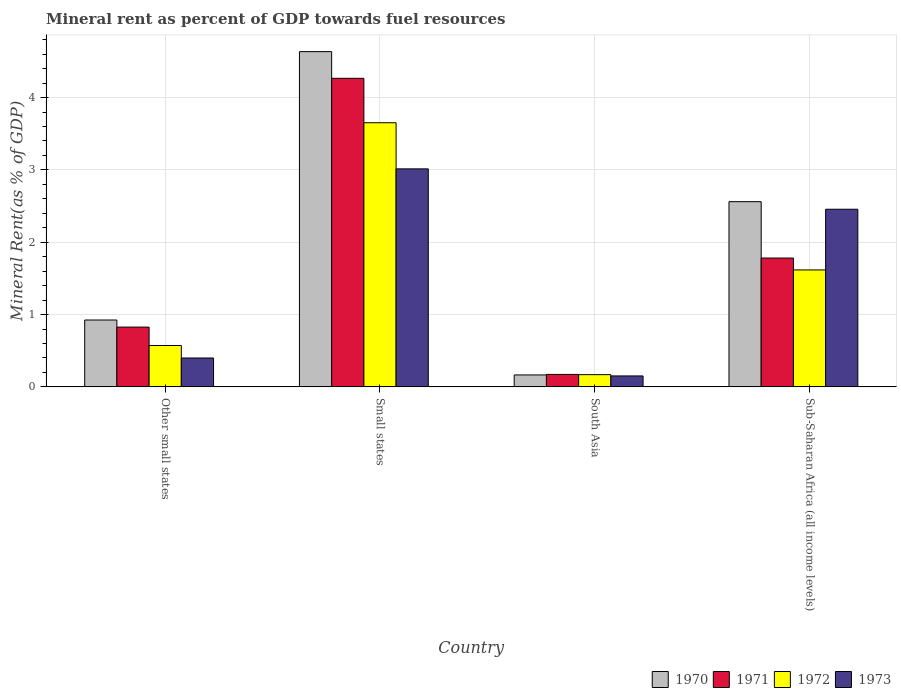How many different coloured bars are there?
Offer a terse response. 4. How many groups of bars are there?
Your answer should be very brief. 4. Are the number of bars per tick equal to the number of legend labels?
Your answer should be very brief. Yes. What is the label of the 4th group of bars from the left?
Keep it short and to the point. Sub-Saharan Africa (all income levels). What is the mineral rent in 1970 in Small states?
Give a very brief answer. 4.63. Across all countries, what is the maximum mineral rent in 1971?
Your response must be concise. 4.27. Across all countries, what is the minimum mineral rent in 1970?
Make the answer very short. 0.16. In which country was the mineral rent in 1971 maximum?
Provide a succinct answer. Small states. What is the total mineral rent in 1973 in the graph?
Offer a very short reply. 6.02. What is the difference between the mineral rent in 1970 in Small states and that in South Asia?
Provide a short and direct response. 4.47. What is the difference between the mineral rent in 1973 in South Asia and the mineral rent in 1971 in Small states?
Offer a very short reply. -4.11. What is the average mineral rent in 1971 per country?
Your answer should be compact. 1.76. What is the difference between the mineral rent of/in 1972 and mineral rent of/in 1970 in Small states?
Give a very brief answer. -0.98. In how many countries, is the mineral rent in 1970 greater than 3.8 %?
Provide a short and direct response. 1. What is the ratio of the mineral rent in 1970 in Other small states to that in Sub-Saharan Africa (all income levels)?
Provide a short and direct response. 0.36. Is the difference between the mineral rent in 1972 in Other small states and Sub-Saharan Africa (all income levels) greater than the difference between the mineral rent in 1970 in Other small states and Sub-Saharan Africa (all income levels)?
Make the answer very short. Yes. What is the difference between the highest and the second highest mineral rent in 1972?
Keep it short and to the point. -1.04. What is the difference between the highest and the lowest mineral rent in 1972?
Offer a very short reply. 3.48. In how many countries, is the mineral rent in 1971 greater than the average mineral rent in 1971 taken over all countries?
Make the answer very short. 2. Is the sum of the mineral rent in 1972 in Small states and Sub-Saharan Africa (all income levels) greater than the maximum mineral rent in 1971 across all countries?
Provide a short and direct response. Yes. What does the 4th bar from the left in Other small states represents?
Make the answer very short. 1973. Are all the bars in the graph horizontal?
Keep it short and to the point. No. How many countries are there in the graph?
Give a very brief answer. 4. Does the graph contain grids?
Provide a succinct answer. Yes. How are the legend labels stacked?
Give a very brief answer. Horizontal. What is the title of the graph?
Keep it short and to the point. Mineral rent as percent of GDP towards fuel resources. Does "2007" appear as one of the legend labels in the graph?
Give a very brief answer. No. What is the label or title of the Y-axis?
Ensure brevity in your answer.  Mineral Rent(as % of GDP). What is the Mineral Rent(as % of GDP) in 1970 in Other small states?
Offer a terse response. 0.92. What is the Mineral Rent(as % of GDP) of 1971 in Other small states?
Your answer should be very brief. 0.83. What is the Mineral Rent(as % of GDP) in 1972 in Other small states?
Offer a terse response. 0.57. What is the Mineral Rent(as % of GDP) of 1973 in Other small states?
Offer a terse response. 0.4. What is the Mineral Rent(as % of GDP) in 1970 in Small states?
Offer a very short reply. 4.63. What is the Mineral Rent(as % of GDP) in 1971 in Small states?
Your answer should be compact. 4.27. What is the Mineral Rent(as % of GDP) in 1972 in Small states?
Your answer should be compact. 3.65. What is the Mineral Rent(as % of GDP) of 1973 in Small states?
Provide a succinct answer. 3.01. What is the Mineral Rent(as % of GDP) of 1970 in South Asia?
Give a very brief answer. 0.16. What is the Mineral Rent(as % of GDP) in 1971 in South Asia?
Provide a succinct answer. 0.17. What is the Mineral Rent(as % of GDP) of 1972 in South Asia?
Provide a short and direct response. 0.17. What is the Mineral Rent(as % of GDP) in 1973 in South Asia?
Offer a terse response. 0.15. What is the Mineral Rent(as % of GDP) of 1970 in Sub-Saharan Africa (all income levels)?
Offer a terse response. 2.56. What is the Mineral Rent(as % of GDP) of 1971 in Sub-Saharan Africa (all income levels)?
Your response must be concise. 1.78. What is the Mineral Rent(as % of GDP) of 1972 in Sub-Saharan Africa (all income levels)?
Make the answer very short. 1.62. What is the Mineral Rent(as % of GDP) of 1973 in Sub-Saharan Africa (all income levels)?
Provide a succinct answer. 2.46. Across all countries, what is the maximum Mineral Rent(as % of GDP) of 1970?
Give a very brief answer. 4.63. Across all countries, what is the maximum Mineral Rent(as % of GDP) of 1971?
Provide a short and direct response. 4.27. Across all countries, what is the maximum Mineral Rent(as % of GDP) of 1972?
Your response must be concise. 3.65. Across all countries, what is the maximum Mineral Rent(as % of GDP) in 1973?
Offer a very short reply. 3.01. Across all countries, what is the minimum Mineral Rent(as % of GDP) of 1970?
Give a very brief answer. 0.16. Across all countries, what is the minimum Mineral Rent(as % of GDP) of 1971?
Make the answer very short. 0.17. Across all countries, what is the minimum Mineral Rent(as % of GDP) in 1972?
Your answer should be compact. 0.17. Across all countries, what is the minimum Mineral Rent(as % of GDP) of 1973?
Give a very brief answer. 0.15. What is the total Mineral Rent(as % of GDP) in 1970 in the graph?
Give a very brief answer. 8.28. What is the total Mineral Rent(as % of GDP) in 1971 in the graph?
Offer a terse response. 7.05. What is the total Mineral Rent(as % of GDP) of 1972 in the graph?
Your answer should be very brief. 6.01. What is the total Mineral Rent(as % of GDP) in 1973 in the graph?
Make the answer very short. 6.02. What is the difference between the Mineral Rent(as % of GDP) in 1970 in Other small states and that in Small states?
Your answer should be very brief. -3.71. What is the difference between the Mineral Rent(as % of GDP) in 1971 in Other small states and that in Small states?
Keep it short and to the point. -3.44. What is the difference between the Mineral Rent(as % of GDP) in 1972 in Other small states and that in Small states?
Provide a succinct answer. -3.08. What is the difference between the Mineral Rent(as % of GDP) in 1973 in Other small states and that in Small states?
Your response must be concise. -2.61. What is the difference between the Mineral Rent(as % of GDP) in 1970 in Other small states and that in South Asia?
Provide a short and direct response. 0.76. What is the difference between the Mineral Rent(as % of GDP) in 1971 in Other small states and that in South Asia?
Keep it short and to the point. 0.65. What is the difference between the Mineral Rent(as % of GDP) in 1972 in Other small states and that in South Asia?
Provide a short and direct response. 0.4. What is the difference between the Mineral Rent(as % of GDP) in 1973 in Other small states and that in South Asia?
Offer a very short reply. 0.25. What is the difference between the Mineral Rent(as % of GDP) in 1970 in Other small states and that in Sub-Saharan Africa (all income levels)?
Offer a very short reply. -1.64. What is the difference between the Mineral Rent(as % of GDP) in 1971 in Other small states and that in Sub-Saharan Africa (all income levels)?
Keep it short and to the point. -0.95. What is the difference between the Mineral Rent(as % of GDP) in 1972 in Other small states and that in Sub-Saharan Africa (all income levels)?
Offer a very short reply. -1.04. What is the difference between the Mineral Rent(as % of GDP) of 1973 in Other small states and that in Sub-Saharan Africa (all income levels)?
Provide a succinct answer. -2.06. What is the difference between the Mineral Rent(as % of GDP) in 1970 in Small states and that in South Asia?
Your response must be concise. 4.47. What is the difference between the Mineral Rent(as % of GDP) of 1971 in Small states and that in South Asia?
Keep it short and to the point. 4.09. What is the difference between the Mineral Rent(as % of GDP) of 1972 in Small states and that in South Asia?
Give a very brief answer. 3.48. What is the difference between the Mineral Rent(as % of GDP) of 1973 in Small states and that in South Asia?
Provide a short and direct response. 2.86. What is the difference between the Mineral Rent(as % of GDP) in 1970 in Small states and that in Sub-Saharan Africa (all income levels)?
Your answer should be very brief. 2.07. What is the difference between the Mineral Rent(as % of GDP) in 1971 in Small states and that in Sub-Saharan Africa (all income levels)?
Your answer should be compact. 2.49. What is the difference between the Mineral Rent(as % of GDP) in 1972 in Small states and that in Sub-Saharan Africa (all income levels)?
Keep it short and to the point. 2.04. What is the difference between the Mineral Rent(as % of GDP) of 1973 in Small states and that in Sub-Saharan Africa (all income levels)?
Give a very brief answer. 0.56. What is the difference between the Mineral Rent(as % of GDP) of 1970 in South Asia and that in Sub-Saharan Africa (all income levels)?
Give a very brief answer. -2.4. What is the difference between the Mineral Rent(as % of GDP) of 1971 in South Asia and that in Sub-Saharan Africa (all income levels)?
Ensure brevity in your answer.  -1.61. What is the difference between the Mineral Rent(as % of GDP) in 1972 in South Asia and that in Sub-Saharan Africa (all income levels)?
Provide a succinct answer. -1.45. What is the difference between the Mineral Rent(as % of GDP) in 1973 in South Asia and that in Sub-Saharan Africa (all income levels)?
Ensure brevity in your answer.  -2.3. What is the difference between the Mineral Rent(as % of GDP) in 1970 in Other small states and the Mineral Rent(as % of GDP) in 1971 in Small states?
Make the answer very short. -3.34. What is the difference between the Mineral Rent(as % of GDP) in 1970 in Other small states and the Mineral Rent(as % of GDP) in 1972 in Small states?
Provide a succinct answer. -2.73. What is the difference between the Mineral Rent(as % of GDP) of 1970 in Other small states and the Mineral Rent(as % of GDP) of 1973 in Small states?
Keep it short and to the point. -2.09. What is the difference between the Mineral Rent(as % of GDP) in 1971 in Other small states and the Mineral Rent(as % of GDP) in 1972 in Small states?
Give a very brief answer. -2.83. What is the difference between the Mineral Rent(as % of GDP) of 1971 in Other small states and the Mineral Rent(as % of GDP) of 1973 in Small states?
Keep it short and to the point. -2.19. What is the difference between the Mineral Rent(as % of GDP) in 1972 in Other small states and the Mineral Rent(as % of GDP) in 1973 in Small states?
Give a very brief answer. -2.44. What is the difference between the Mineral Rent(as % of GDP) in 1970 in Other small states and the Mineral Rent(as % of GDP) in 1971 in South Asia?
Give a very brief answer. 0.75. What is the difference between the Mineral Rent(as % of GDP) of 1970 in Other small states and the Mineral Rent(as % of GDP) of 1972 in South Asia?
Make the answer very short. 0.76. What is the difference between the Mineral Rent(as % of GDP) of 1970 in Other small states and the Mineral Rent(as % of GDP) of 1973 in South Asia?
Ensure brevity in your answer.  0.77. What is the difference between the Mineral Rent(as % of GDP) of 1971 in Other small states and the Mineral Rent(as % of GDP) of 1972 in South Asia?
Ensure brevity in your answer.  0.66. What is the difference between the Mineral Rent(as % of GDP) of 1971 in Other small states and the Mineral Rent(as % of GDP) of 1973 in South Asia?
Offer a terse response. 0.68. What is the difference between the Mineral Rent(as % of GDP) in 1972 in Other small states and the Mineral Rent(as % of GDP) in 1973 in South Asia?
Keep it short and to the point. 0.42. What is the difference between the Mineral Rent(as % of GDP) of 1970 in Other small states and the Mineral Rent(as % of GDP) of 1971 in Sub-Saharan Africa (all income levels)?
Give a very brief answer. -0.86. What is the difference between the Mineral Rent(as % of GDP) of 1970 in Other small states and the Mineral Rent(as % of GDP) of 1972 in Sub-Saharan Africa (all income levels)?
Ensure brevity in your answer.  -0.69. What is the difference between the Mineral Rent(as % of GDP) of 1970 in Other small states and the Mineral Rent(as % of GDP) of 1973 in Sub-Saharan Africa (all income levels)?
Your answer should be very brief. -1.53. What is the difference between the Mineral Rent(as % of GDP) in 1971 in Other small states and the Mineral Rent(as % of GDP) in 1972 in Sub-Saharan Africa (all income levels)?
Make the answer very short. -0.79. What is the difference between the Mineral Rent(as % of GDP) of 1971 in Other small states and the Mineral Rent(as % of GDP) of 1973 in Sub-Saharan Africa (all income levels)?
Keep it short and to the point. -1.63. What is the difference between the Mineral Rent(as % of GDP) in 1972 in Other small states and the Mineral Rent(as % of GDP) in 1973 in Sub-Saharan Africa (all income levels)?
Make the answer very short. -1.88. What is the difference between the Mineral Rent(as % of GDP) in 1970 in Small states and the Mineral Rent(as % of GDP) in 1971 in South Asia?
Your response must be concise. 4.46. What is the difference between the Mineral Rent(as % of GDP) in 1970 in Small states and the Mineral Rent(as % of GDP) in 1972 in South Asia?
Give a very brief answer. 4.47. What is the difference between the Mineral Rent(as % of GDP) in 1970 in Small states and the Mineral Rent(as % of GDP) in 1973 in South Asia?
Provide a succinct answer. 4.48. What is the difference between the Mineral Rent(as % of GDP) in 1971 in Small states and the Mineral Rent(as % of GDP) in 1972 in South Asia?
Give a very brief answer. 4.1. What is the difference between the Mineral Rent(as % of GDP) in 1971 in Small states and the Mineral Rent(as % of GDP) in 1973 in South Asia?
Your answer should be compact. 4.11. What is the difference between the Mineral Rent(as % of GDP) of 1972 in Small states and the Mineral Rent(as % of GDP) of 1973 in South Asia?
Your answer should be compact. 3.5. What is the difference between the Mineral Rent(as % of GDP) of 1970 in Small states and the Mineral Rent(as % of GDP) of 1971 in Sub-Saharan Africa (all income levels)?
Your answer should be compact. 2.85. What is the difference between the Mineral Rent(as % of GDP) in 1970 in Small states and the Mineral Rent(as % of GDP) in 1972 in Sub-Saharan Africa (all income levels)?
Make the answer very short. 3.02. What is the difference between the Mineral Rent(as % of GDP) in 1970 in Small states and the Mineral Rent(as % of GDP) in 1973 in Sub-Saharan Africa (all income levels)?
Give a very brief answer. 2.18. What is the difference between the Mineral Rent(as % of GDP) in 1971 in Small states and the Mineral Rent(as % of GDP) in 1972 in Sub-Saharan Africa (all income levels)?
Provide a succinct answer. 2.65. What is the difference between the Mineral Rent(as % of GDP) in 1971 in Small states and the Mineral Rent(as % of GDP) in 1973 in Sub-Saharan Africa (all income levels)?
Keep it short and to the point. 1.81. What is the difference between the Mineral Rent(as % of GDP) in 1972 in Small states and the Mineral Rent(as % of GDP) in 1973 in Sub-Saharan Africa (all income levels)?
Make the answer very short. 1.2. What is the difference between the Mineral Rent(as % of GDP) of 1970 in South Asia and the Mineral Rent(as % of GDP) of 1971 in Sub-Saharan Africa (all income levels)?
Your answer should be very brief. -1.62. What is the difference between the Mineral Rent(as % of GDP) of 1970 in South Asia and the Mineral Rent(as % of GDP) of 1972 in Sub-Saharan Africa (all income levels)?
Provide a short and direct response. -1.45. What is the difference between the Mineral Rent(as % of GDP) of 1970 in South Asia and the Mineral Rent(as % of GDP) of 1973 in Sub-Saharan Africa (all income levels)?
Ensure brevity in your answer.  -2.29. What is the difference between the Mineral Rent(as % of GDP) of 1971 in South Asia and the Mineral Rent(as % of GDP) of 1972 in Sub-Saharan Africa (all income levels)?
Your answer should be very brief. -1.44. What is the difference between the Mineral Rent(as % of GDP) in 1971 in South Asia and the Mineral Rent(as % of GDP) in 1973 in Sub-Saharan Africa (all income levels)?
Provide a succinct answer. -2.28. What is the difference between the Mineral Rent(as % of GDP) of 1972 in South Asia and the Mineral Rent(as % of GDP) of 1973 in Sub-Saharan Africa (all income levels)?
Your answer should be very brief. -2.29. What is the average Mineral Rent(as % of GDP) of 1970 per country?
Your response must be concise. 2.07. What is the average Mineral Rent(as % of GDP) in 1971 per country?
Give a very brief answer. 1.76. What is the average Mineral Rent(as % of GDP) of 1972 per country?
Your answer should be very brief. 1.5. What is the average Mineral Rent(as % of GDP) of 1973 per country?
Ensure brevity in your answer.  1.5. What is the difference between the Mineral Rent(as % of GDP) in 1970 and Mineral Rent(as % of GDP) in 1971 in Other small states?
Offer a very short reply. 0.1. What is the difference between the Mineral Rent(as % of GDP) of 1970 and Mineral Rent(as % of GDP) of 1972 in Other small states?
Make the answer very short. 0.35. What is the difference between the Mineral Rent(as % of GDP) in 1970 and Mineral Rent(as % of GDP) in 1973 in Other small states?
Provide a short and direct response. 0.53. What is the difference between the Mineral Rent(as % of GDP) of 1971 and Mineral Rent(as % of GDP) of 1972 in Other small states?
Ensure brevity in your answer.  0.25. What is the difference between the Mineral Rent(as % of GDP) in 1971 and Mineral Rent(as % of GDP) in 1973 in Other small states?
Offer a very short reply. 0.43. What is the difference between the Mineral Rent(as % of GDP) of 1972 and Mineral Rent(as % of GDP) of 1973 in Other small states?
Give a very brief answer. 0.17. What is the difference between the Mineral Rent(as % of GDP) in 1970 and Mineral Rent(as % of GDP) in 1971 in Small states?
Your response must be concise. 0.37. What is the difference between the Mineral Rent(as % of GDP) in 1970 and Mineral Rent(as % of GDP) in 1972 in Small states?
Give a very brief answer. 0.98. What is the difference between the Mineral Rent(as % of GDP) of 1970 and Mineral Rent(as % of GDP) of 1973 in Small states?
Offer a very short reply. 1.62. What is the difference between the Mineral Rent(as % of GDP) of 1971 and Mineral Rent(as % of GDP) of 1972 in Small states?
Give a very brief answer. 0.61. What is the difference between the Mineral Rent(as % of GDP) of 1971 and Mineral Rent(as % of GDP) of 1973 in Small states?
Offer a terse response. 1.25. What is the difference between the Mineral Rent(as % of GDP) of 1972 and Mineral Rent(as % of GDP) of 1973 in Small states?
Provide a short and direct response. 0.64. What is the difference between the Mineral Rent(as % of GDP) of 1970 and Mineral Rent(as % of GDP) of 1971 in South Asia?
Make the answer very short. -0.01. What is the difference between the Mineral Rent(as % of GDP) in 1970 and Mineral Rent(as % of GDP) in 1972 in South Asia?
Offer a very short reply. -0. What is the difference between the Mineral Rent(as % of GDP) of 1970 and Mineral Rent(as % of GDP) of 1973 in South Asia?
Your response must be concise. 0.01. What is the difference between the Mineral Rent(as % of GDP) in 1971 and Mineral Rent(as % of GDP) in 1972 in South Asia?
Your response must be concise. 0. What is the difference between the Mineral Rent(as % of GDP) in 1971 and Mineral Rent(as % of GDP) in 1973 in South Asia?
Your answer should be compact. 0.02. What is the difference between the Mineral Rent(as % of GDP) of 1972 and Mineral Rent(as % of GDP) of 1973 in South Asia?
Keep it short and to the point. 0.02. What is the difference between the Mineral Rent(as % of GDP) in 1970 and Mineral Rent(as % of GDP) in 1971 in Sub-Saharan Africa (all income levels)?
Keep it short and to the point. 0.78. What is the difference between the Mineral Rent(as % of GDP) in 1970 and Mineral Rent(as % of GDP) in 1972 in Sub-Saharan Africa (all income levels)?
Your answer should be very brief. 0.94. What is the difference between the Mineral Rent(as % of GDP) in 1970 and Mineral Rent(as % of GDP) in 1973 in Sub-Saharan Africa (all income levels)?
Provide a short and direct response. 0.1. What is the difference between the Mineral Rent(as % of GDP) in 1971 and Mineral Rent(as % of GDP) in 1972 in Sub-Saharan Africa (all income levels)?
Your answer should be compact. 0.16. What is the difference between the Mineral Rent(as % of GDP) of 1971 and Mineral Rent(as % of GDP) of 1973 in Sub-Saharan Africa (all income levels)?
Your answer should be compact. -0.67. What is the difference between the Mineral Rent(as % of GDP) in 1972 and Mineral Rent(as % of GDP) in 1973 in Sub-Saharan Africa (all income levels)?
Keep it short and to the point. -0.84. What is the ratio of the Mineral Rent(as % of GDP) in 1970 in Other small states to that in Small states?
Your answer should be compact. 0.2. What is the ratio of the Mineral Rent(as % of GDP) of 1971 in Other small states to that in Small states?
Your answer should be very brief. 0.19. What is the ratio of the Mineral Rent(as % of GDP) in 1972 in Other small states to that in Small states?
Keep it short and to the point. 0.16. What is the ratio of the Mineral Rent(as % of GDP) in 1973 in Other small states to that in Small states?
Provide a succinct answer. 0.13. What is the ratio of the Mineral Rent(as % of GDP) of 1970 in Other small states to that in South Asia?
Offer a terse response. 5.61. What is the ratio of the Mineral Rent(as % of GDP) of 1971 in Other small states to that in South Asia?
Your response must be concise. 4.8. What is the ratio of the Mineral Rent(as % of GDP) in 1972 in Other small states to that in South Asia?
Keep it short and to the point. 3.38. What is the ratio of the Mineral Rent(as % of GDP) in 1973 in Other small states to that in South Asia?
Your response must be concise. 2.64. What is the ratio of the Mineral Rent(as % of GDP) of 1970 in Other small states to that in Sub-Saharan Africa (all income levels)?
Keep it short and to the point. 0.36. What is the ratio of the Mineral Rent(as % of GDP) of 1971 in Other small states to that in Sub-Saharan Africa (all income levels)?
Give a very brief answer. 0.46. What is the ratio of the Mineral Rent(as % of GDP) of 1972 in Other small states to that in Sub-Saharan Africa (all income levels)?
Provide a short and direct response. 0.35. What is the ratio of the Mineral Rent(as % of GDP) of 1973 in Other small states to that in Sub-Saharan Africa (all income levels)?
Provide a succinct answer. 0.16. What is the ratio of the Mineral Rent(as % of GDP) of 1970 in Small states to that in South Asia?
Provide a succinct answer. 28.13. What is the ratio of the Mineral Rent(as % of GDP) of 1971 in Small states to that in South Asia?
Provide a succinct answer. 24.77. What is the ratio of the Mineral Rent(as % of GDP) of 1972 in Small states to that in South Asia?
Offer a very short reply. 21.6. What is the ratio of the Mineral Rent(as % of GDP) in 1973 in Small states to that in South Asia?
Keep it short and to the point. 19.93. What is the ratio of the Mineral Rent(as % of GDP) of 1970 in Small states to that in Sub-Saharan Africa (all income levels)?
Your response must be concise. 1.81. What is the ratio of the Mineral Rent(as % of GDP) in 1971 in Small states to that in Sub-Saharan Africa (all income levels)?
Provide a succinct answer. 2.4. What is the ratio of the Mineral Rent(as % of GDP) in 1972 in Small states to that in Sub-Saharan Africa (all income levels)?
Provide a succinct answer. 2.26. What is the ratio of the Mineral Rent(as % of GDP) in 1973 in Small states to that in Sub-Saharan Africa (all income levels)?
Keep it short and to the point. 1.23. What is the ratio of the Mineral Rent(as % of GDP) of 1970 in South Asia to that in Sub-Saharan Africa (all income levels)?
Offer a very short reply. 0.06. What is the ratio of the Mineral Rent(as % of GDP) of 1971 in South Asia to that in Sub-Saharan Africa (all income levels)?
Your answer should be very brief. 0.1. What is the ratio of the Mineral Rent(as % of GDP) in 1972 in South Asia to that in Sub-Saharan Africa (all income levels)?
Your answer should be very brief. 0.1. What is the ratio of the Mineral Rent(as % of GDP) in 1973 in South Asia to that in Sub-Saharan Africa (all income levels)?
Your response must be concise. 0.06. What is the difference between the highest and the second highest Mineral Rent(as % of GDP) in 1970?
Ensure brevity in your answer.  2.07. What is the difference between the highest and the second highest Mineral Rent(as % of GDP) of 1971?
Make the answer very short. 2.49. What is the difference between the highest and the second highest Mineral Rent(as % of GDP) of 1972?
Your answer should be compact. 2.04. What is the difference between the highest and the second highest Mineral Rent(as % of GDP) of 1973?
Offer a terse response. 0.56. What is the difference between the highest and the lowest Mineral Rent(as % of GDP) in 1970?
Offer a very short reply. 4.47. What is the difference between the highest and the lowest Mineral Rent(as % of GDP) in 1971?
Keep it short and to the point. 4.09. What is the difference between the highest and the lowest Mineral Rent(as % of GDP) in 1972?
Make the answer very short. 3.48. What is the difference between the highest and the lowest Mineral Rent(as % of GDP) of 1973?
Provide a succinct answer. 2.86. 